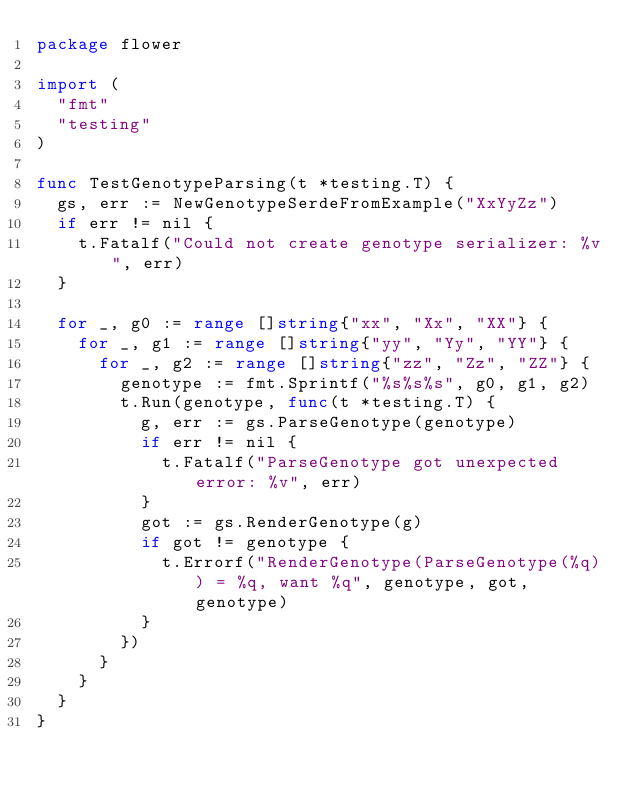Convert code to text. <code><loc_0><loc_0><loc_500><loc_500><_Go_>package flower

import (
	"fmt"
	"testing"
)

func TestGenotypeParsing(t *testing.T) {
	gs, err := NewGenotypeSerdeFromExample("XxYyZz")
	if err != nil {
		t.Fatalf("Could not create genotype serializer: %v", err)
	}

	for _, g0 := range []string{"xx", "Xx", "XX"} {
		for _, g1 := range []string{"yy", "Yy", "YY"} {
			for _, g2 := range []string{"zz", "Zz", "ZZ"} {
				genotype := fmt.Sprintf("%s%s%s", g0, g1, g2)
				t.Run(genotype, func(t *testing.T) {
					g, err := gs.ParseGenotype(genotype)
					if err != nil {
						t.Fatalf("ParseGenotype got unexpected error: %v", err)
					}
					got := gs.RenderGenotype(g)
					if got != genotype {
						t.Errorf("RenderGenotype(ParseGenotype(%q)) = %q, want %q", genotype, got, genotype)
					}
				})
			}
		}
	}
}
</code> 